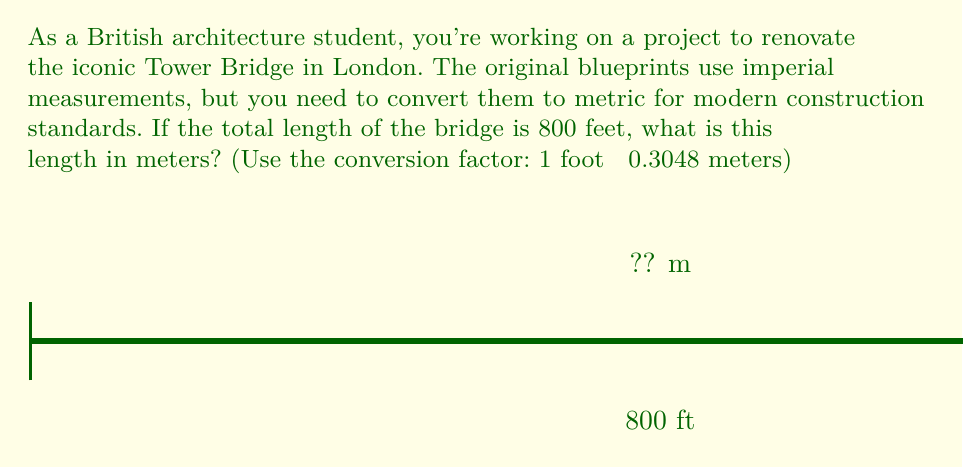Teach me how to tackle this problem. To convert the length of Tower Bridge from feet to meters, we'll use the given conversion factor and follow these steps:

1) The conversion factor is: 1 foot ≈ 0.3048 meters

2) We need to multiply the length in feet by this factor:

   $$ \text{Length in meters} = \text{Length in feet} \times \text{Conversion factor} $$

3) Substituting the values:

   $$ \text{Length in meters} = 800 \text{ ft} \times 0.3048 \text{ m/ft} $$

4) Calculating:

   $$ \text{Length in meters} = 243.84 \text{ m} $$

5) Rounding to two decimal places for practical architectural use:

   $$ \text{Length in meters} \approx 243.84 \text{ m} $$

Thus, the 800-foot length of Tower Bridge is approximately 243.84 meters.
Answer: 243.84 m 